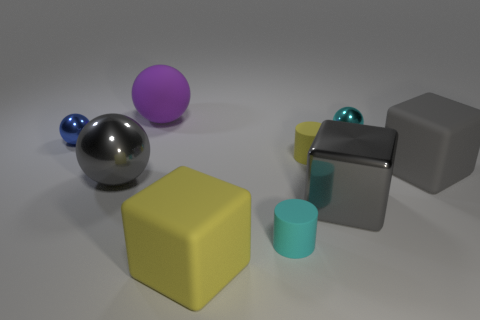Subtract all purple balls. How many balls are left? 3 Subtract all gray spheres. How many spheres are left? 3 Subtract all red spheres. Subtract all blue cylinders. How many spheres are left? 4 Add 1 small gray rubber cubes. How many objects exist? 10 Subtract all cylinders. How many objects are left? 7 Add 3 blue objects. How many blue objects exist? 4 Subtract 0 green cylinders. How many objects are left? 9 Subtract all spheres. Subtract all large brown metal blocks. How many objects are left? 5 Add 4 small cyan spheres. How many small cyan spheres are left? 5 